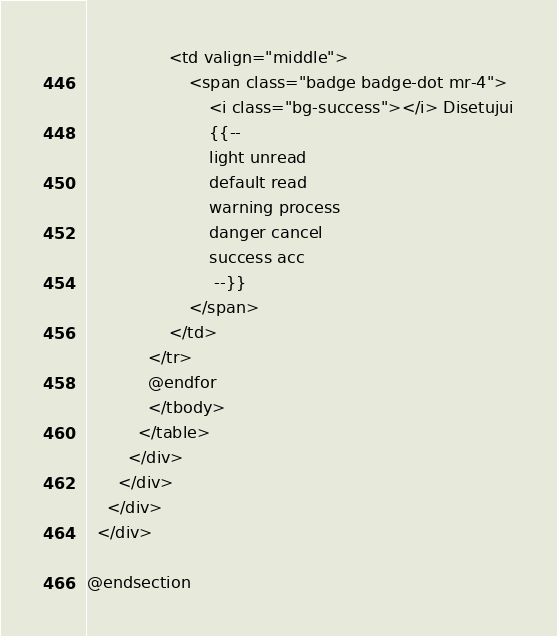<code> <loc_0><loc_0><loc_500><loc_500><_PHP_>                <td valign="middle">
                    <span class="badge badge-dot mr-4">
                        <i class="bg-success"></i> Disetujui
                        {{-- 
                        light unread
						default read
						warning process
						danger cancel
						success acc
                         --}}
                    </span>
                </td>
            </tr>
            @endfor
            </tbody>
          </table>
        </div>
      </div>
    </div>
  </div>

@endsection</code> 